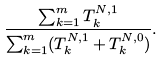<formula> <loc_0><loc_0><loc_500><loc_500>\frac { \sum _ { k = 1 } ^ { m } T ^ { N , 1 } _ { k } } { \sum _ { k = 1 } ^ { m } ( T ^ { N , 1 } _ { k } + T ^ { N , 0 } _ { k } ) } .</formula> 